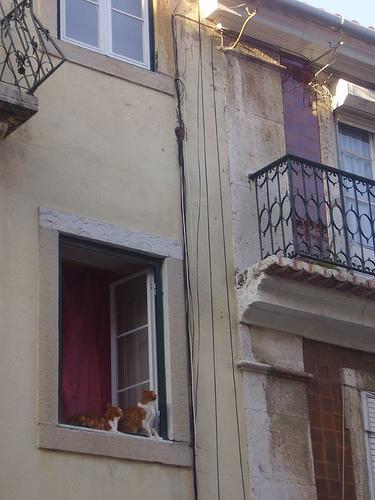Is that a cat in the window?
Quick response, please. Yes. How many windows are open?
Keep it brief. 1. What animal is this?
Give a very brief answer. Cat. Is the cat inside or outside the house?
Write a very short answer. Inside. How many cats are in this photo?
Quick response, please. 2. What animal is peeking out the window?
Short answer required. Cat. Why are these cats at the window?
Give a very brief answer. Because they can be. Is the sun shining?
Quick response, please. Yes. 